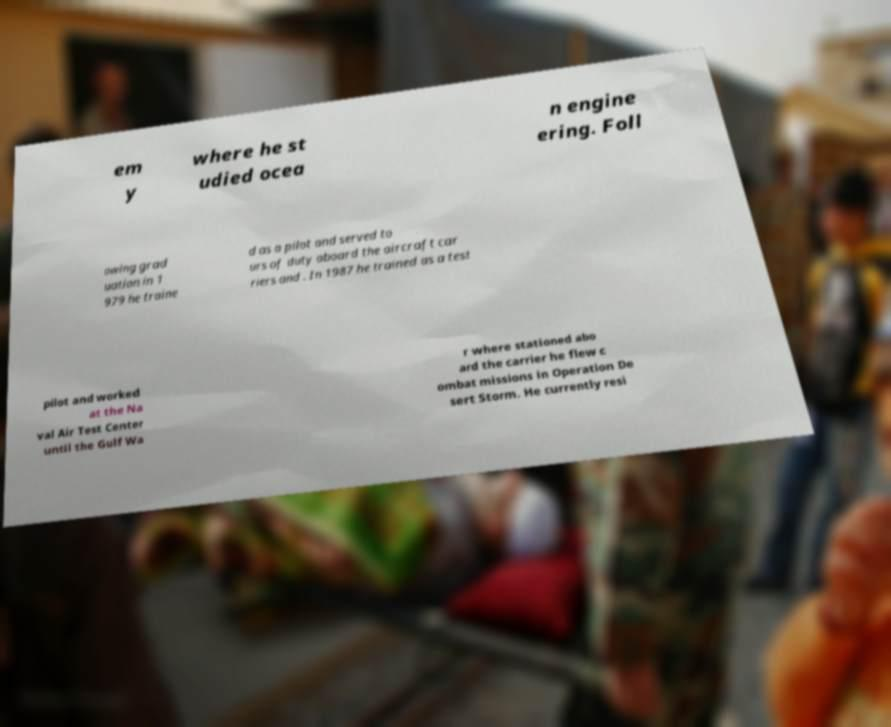There's text embedded in this image that I need extracted. Can you transcribe it verbatim? em y where he st udied ocea n engine ering. Foll owing grad uation in 1 979 he traine d as a pilot and served to urs of duty aboard the aircraft car riers and . In 1987 he trained as a test pilot and worked at the Na val Air Test Center until the Gulf Wa r where stationed abo ard the carrier he flew c ombat missions in Operation De sert Storm. He currently resi 